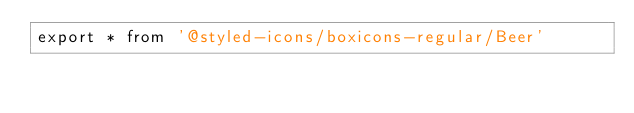Convert code to text. <code><loc_0><loc_0><loc_500><loc_500><_TypeScript_>export * from '@styled-icons/boxicons-regular/Beer'</code> 